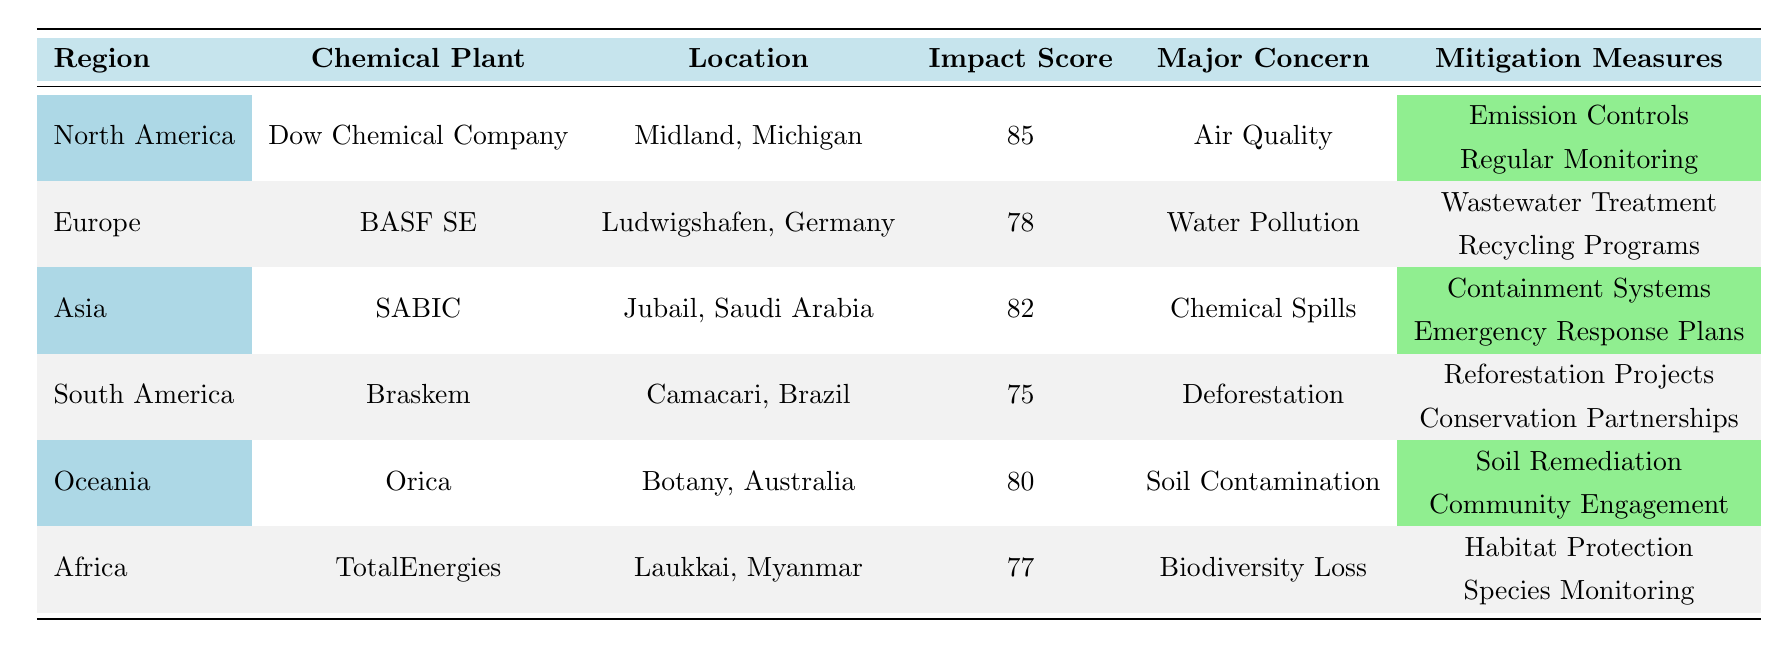What is the impact score of the Dow Chemical Company? Looking at the row for the Dow Chemical Company in North America, the Impact Score is listed as 85.
Answer: 85 Which region has the lowest impact score for chemical plants? South America has the lowest documented Impact Score of 75 for Braskem, while other regions have scores higher than this.
Answer: South America What major concern is associated with BASF SE? Upon reviewing BASF SE, the Major Concern listed is Water Pollution.
Answer: Water Pollution What are the mitigation measures for SABIC? The mitigation measures provided for SABIC include Containment Systems and Emergency Response Plans, as specified in the table.
Answer: Containment Systems, Emergency Response Plans Is the impact score for Orica higher than that of TotalEnergies? The Impact Score for Orica is 80, while TotalEnergies has an Impact Score of 77. Therefore, Orica's score is higher.
Answer: Yes What is the average impact score of the chemical plants listed? The scores are 85, 78, 82, 75, 80, and 77. Their sum is 477; dividing by 6 gives an average of 79.5.
Answer: 79.5 Which chemical plant is concerned with soil contamination? The table under Oceania shows Orica as the chemical plant with the major concern being Soil Contamination.
Answer: Orica What type of mitigation measures does Braskem engage in? Braskem employs Reforestation Projects and Conservation Partnerships as its mitigation measures, detailed in the table.
Answer: Reforestation Projects, Conservation Partnerships Are biodiversity loss concerns related to any chemical plant in Africa? Yes, TotalEnergies in Africa has the Major Concern of Biodiversity Loss according to the table.
Answer: Yes Which chemical plant has the highest impact score, and what is the score? The Dow Chemical Company has the highest Impact Score of 85, making it the top-rated plant in the table.
Answer: Dow Chemical Company, 85 